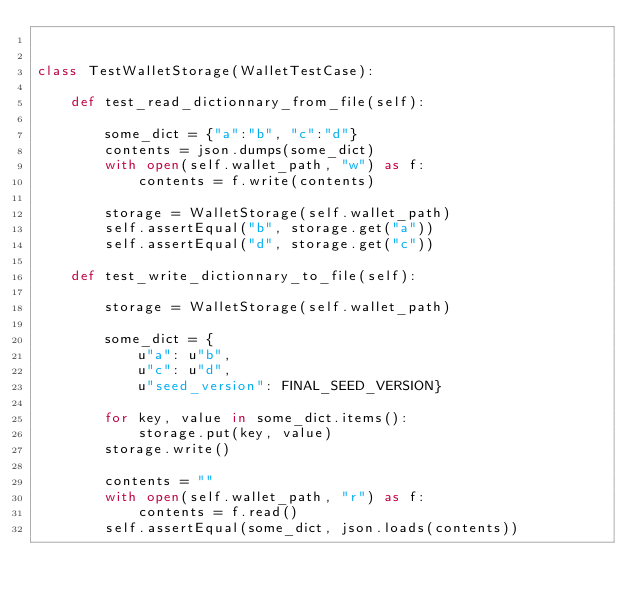<code> <loc_0><loc_0><loc_500><loc_500><_Python_>

class TestWalletStorage(WalletTestCase):

    def test_read_dictionnary_from_file(self):

        some_dict = {"a":"b", "c":"d"}
        contents = json.dumps(some_dict)
        with open(self.wallet_path, "w") as f:
            contents = f.write(contents)

        storage = WalletStorage(self.wallet_path)
        self.assertEqual("b", storage.get("a"))
        self.assertEqual("d", storage.get("c"))

    def test_write_dictionnary_to_file(self):

        storage = WalletStorage(self.wallet_path)

        some_dict = {
            u"a": u"b",
            u"c": u"d",
            u"seed_version": FINAL_SEED_VERSION}

        for key, value in some_dict.items():
            storage.put(key, value)
        storage.write()

        contents = ""
        with open(self.wallet_path, "r") as f:
            contents = f.read()
        self.assertEqual(some_dict, json.loads(contents))
</code> 